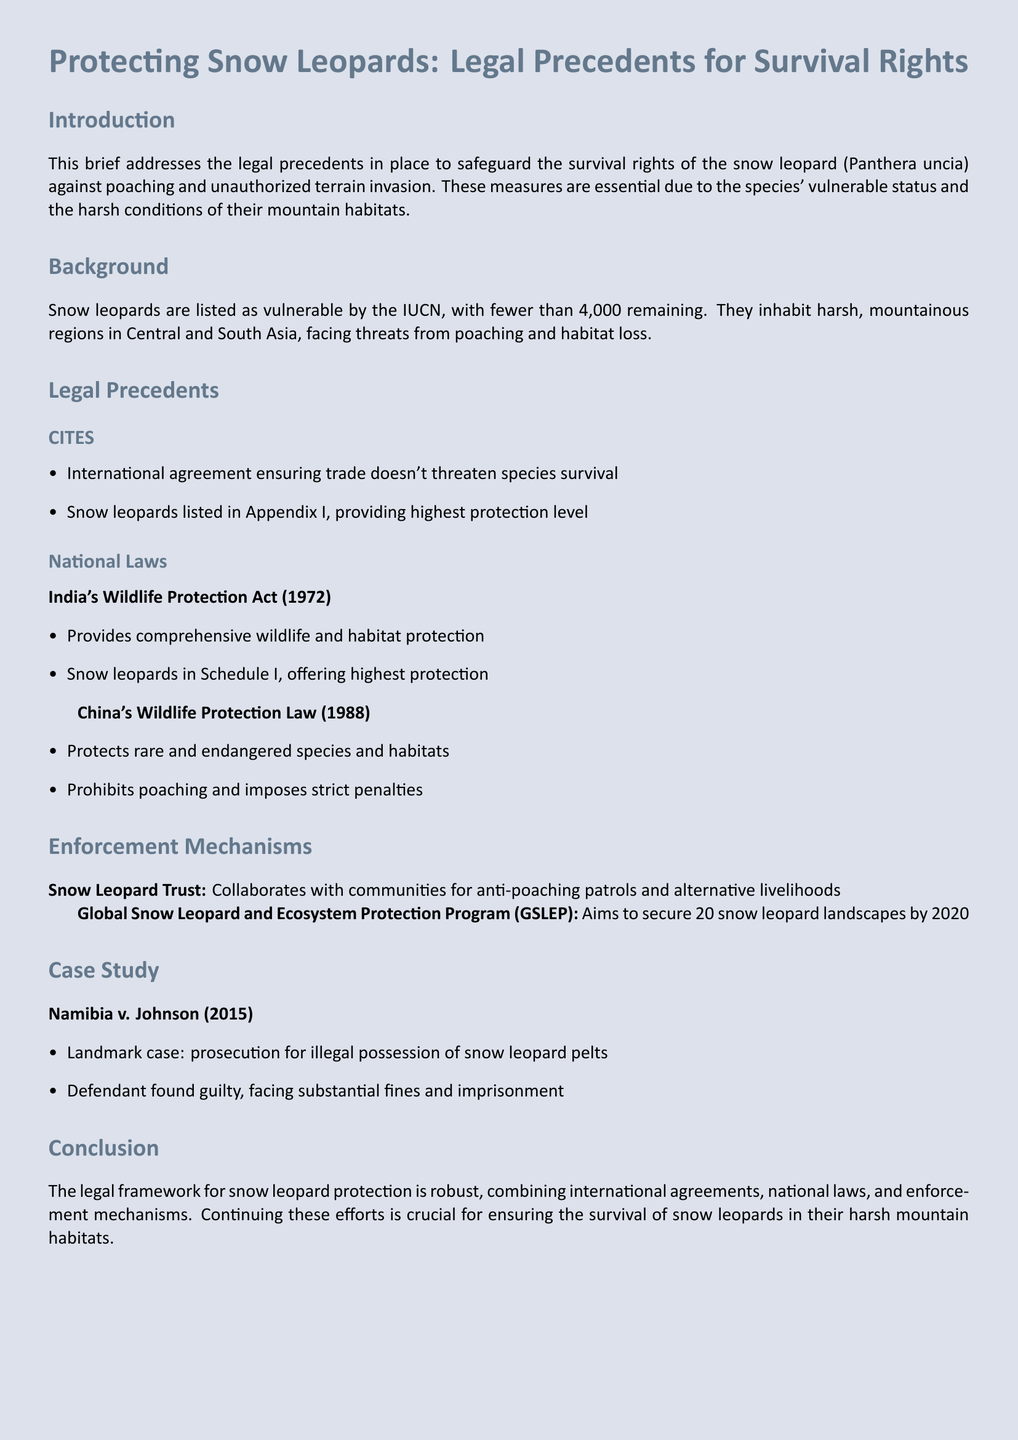What is the vulnerable status of snow leopards? The document states that snow leopards are listed as vulnerable by the IUCN.
Answer: vulnerable How many snow leopards are estimated to remain? The document mentions there are fewer than 4,000 remaining snow leopards.
Answer: fewer than 4,000 What international agreement provides the highest protection level for snow leopards? The text refers to CITES as the international agreement ensuring protection.
Answer: CITES Which act provides comprehensive wildlife protection in India? The document identifies India's Wildlife Protection Act (1972) as the relevant act.
Answer: India's Wildlife Protection Act (1972) What is the aim of the Global Snow Leopard and Ecosystem Protection Program? The document states that it aims to secure 20 snow leopard landscapes by 2020.
Answer: 20 snow leopard landscapes by 2020 What was the outcome of the case Namibia v. Johnson? The document states that the defendant was found guilty and faced substantial fines and imprisonment.
Answer: guilty, fines, imprisonment What kind of penalties does China's Wildlife Protection Law impose? The document specifies that it imposes strict penalties for poaching.
Answer: strict penalties What entity collaborates with communities for anti-poaching efforts? The document mentions the Snow Leopard Trust as collaborating for anti-poaching patrols.
Answer: Snow Leopard Trust 